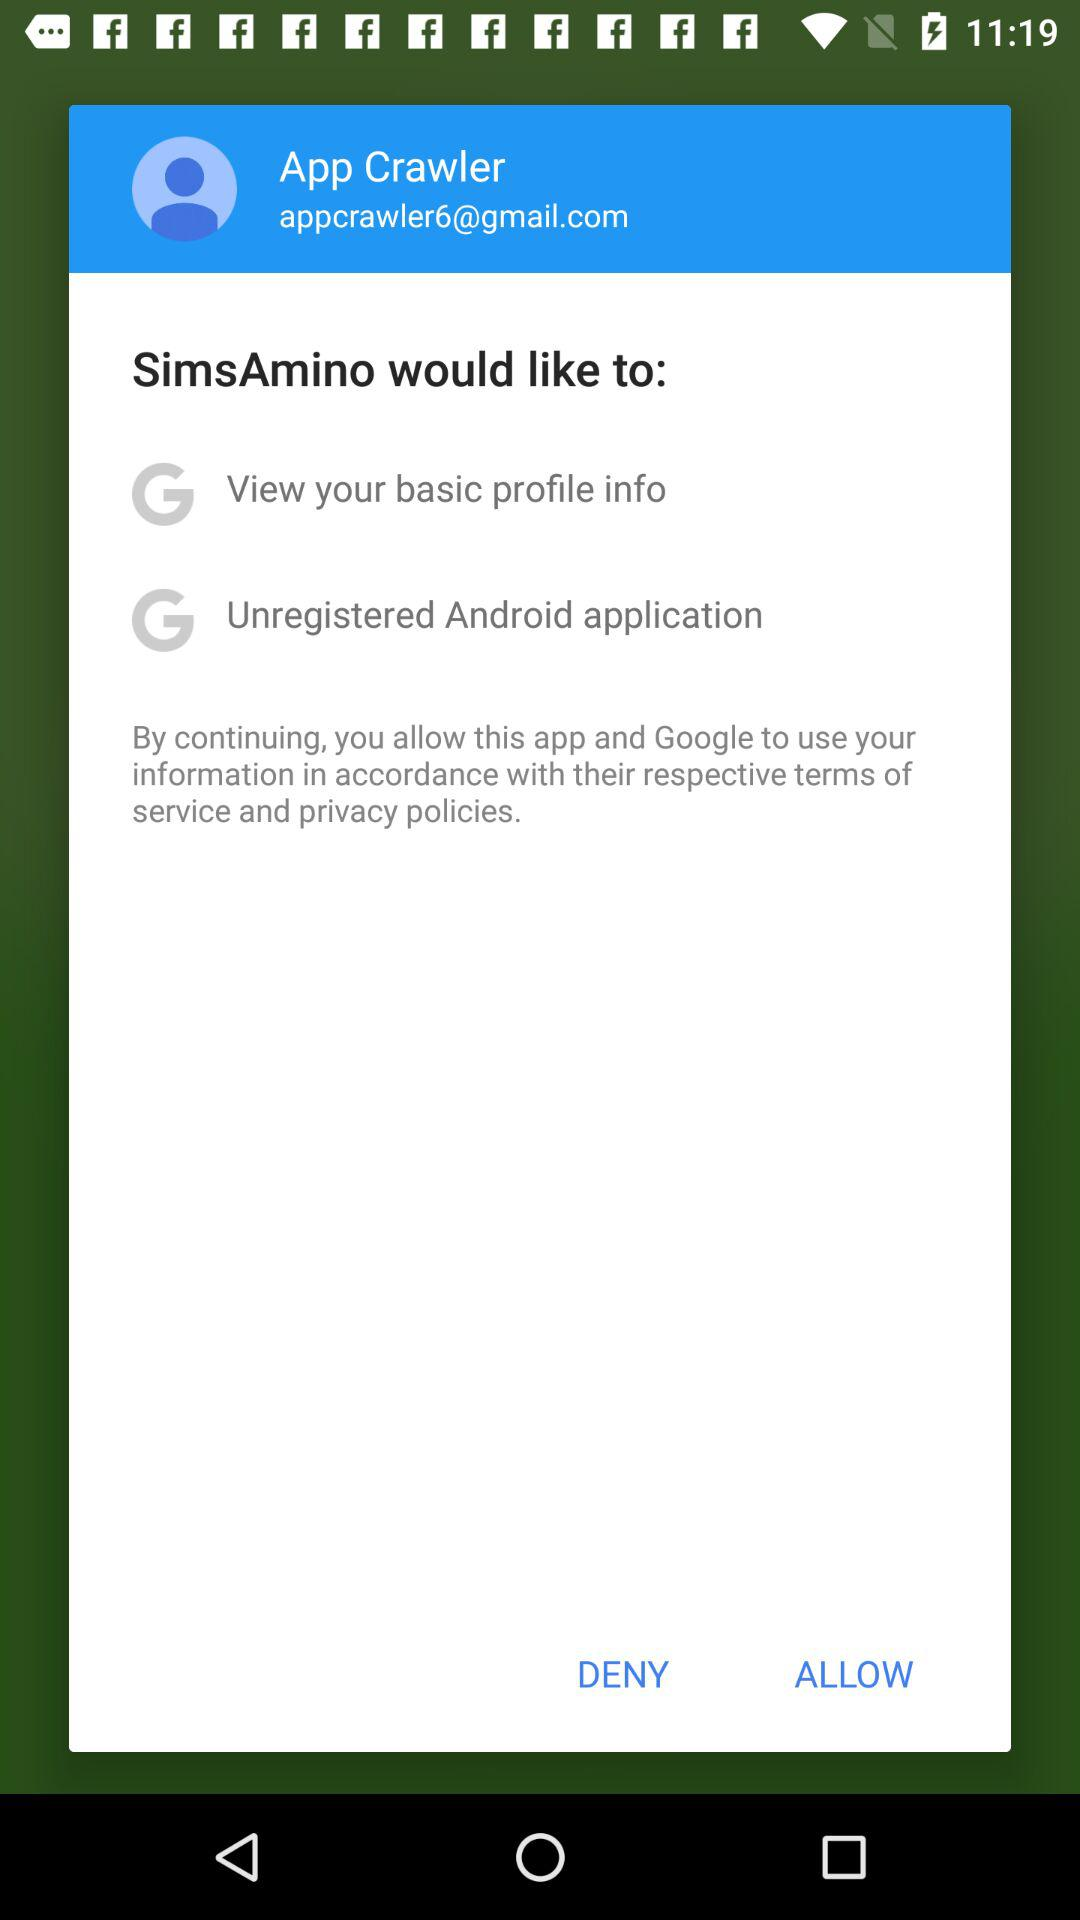What is the name of the user? The name of the user is App Crawler. 